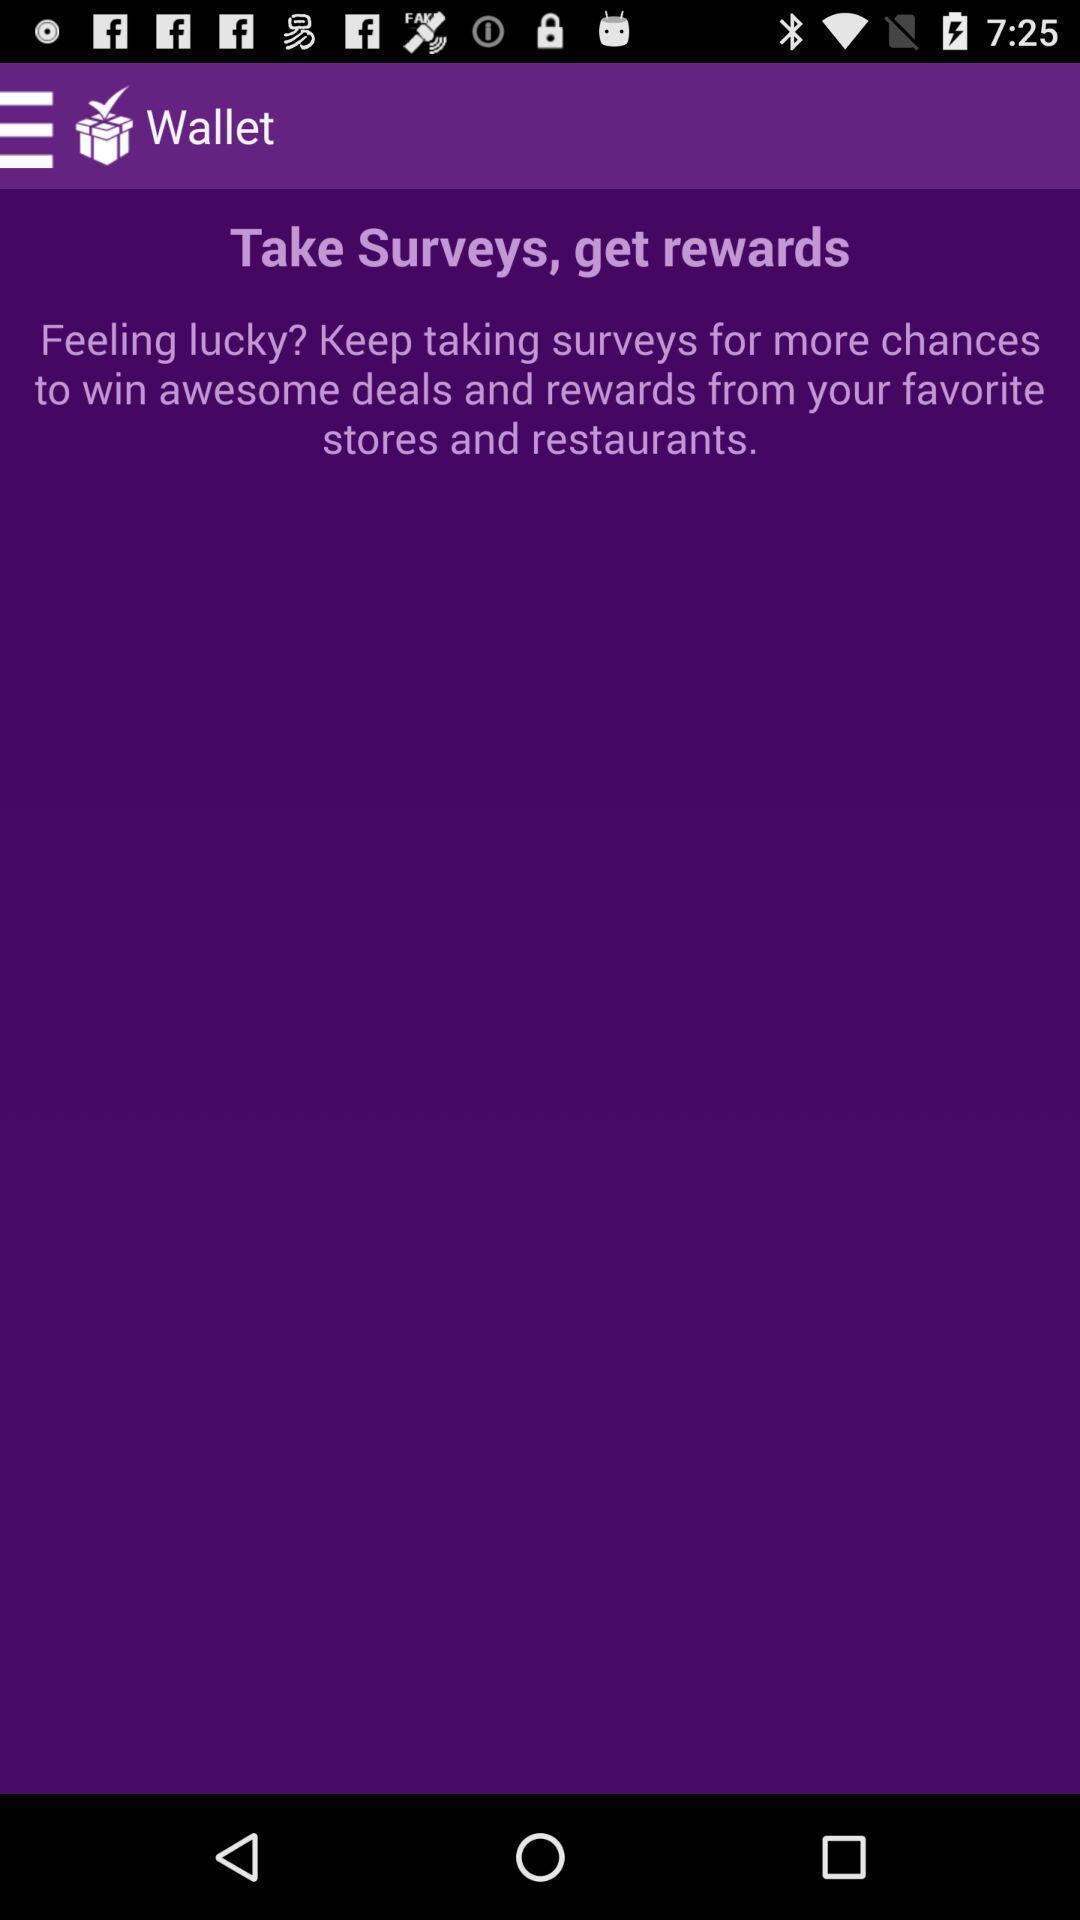Describe this image in words. Page shows the wallet. 